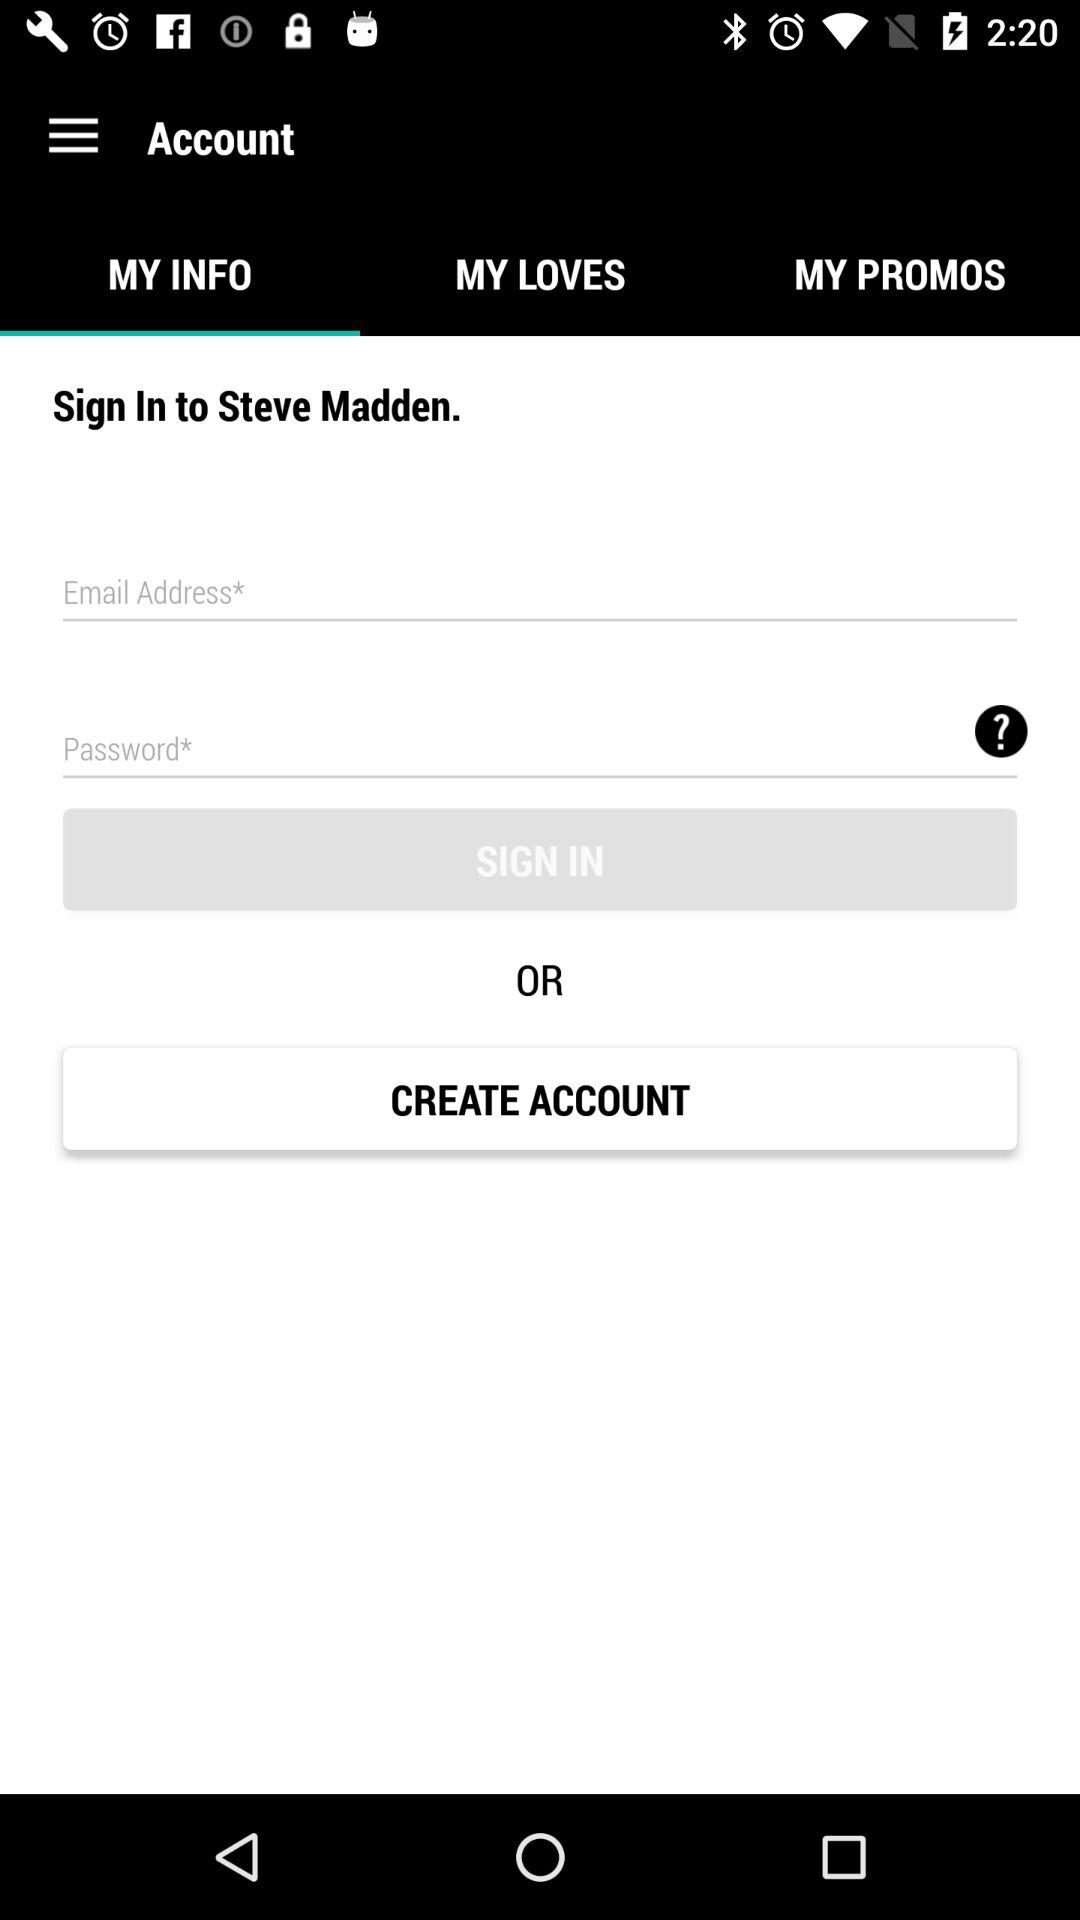How many input fields are required to sign in?
Answer the question using a single word or phrase. 2 